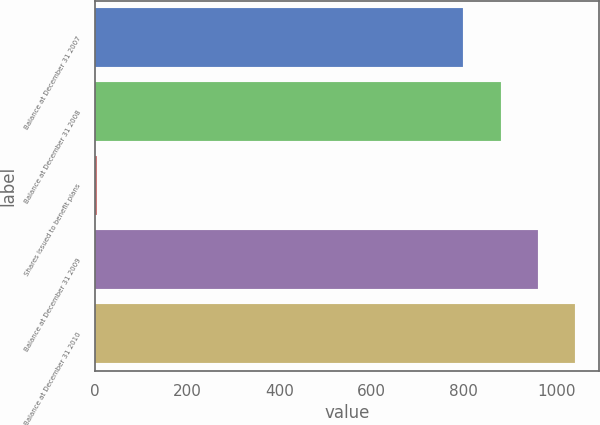Convert chart to OTSL. <chart><loc_0><loc_0><loc_500><loc_500><bar_chart><fcel>Balance at December 31 2007<fcel>Balance at December 31 2008<fcel>Shares issued to benefit plans<fcel>Balance at December 31 2009<fcel>Balance at December 31 2010<nl><fcel>799<fcel>879.9<fcel>4<fcel>960.8<fcel>1041.7<nl></chart> 